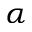<formula> <loc_0><loc_0><loc_500><loc_500>\alpha</formula> 